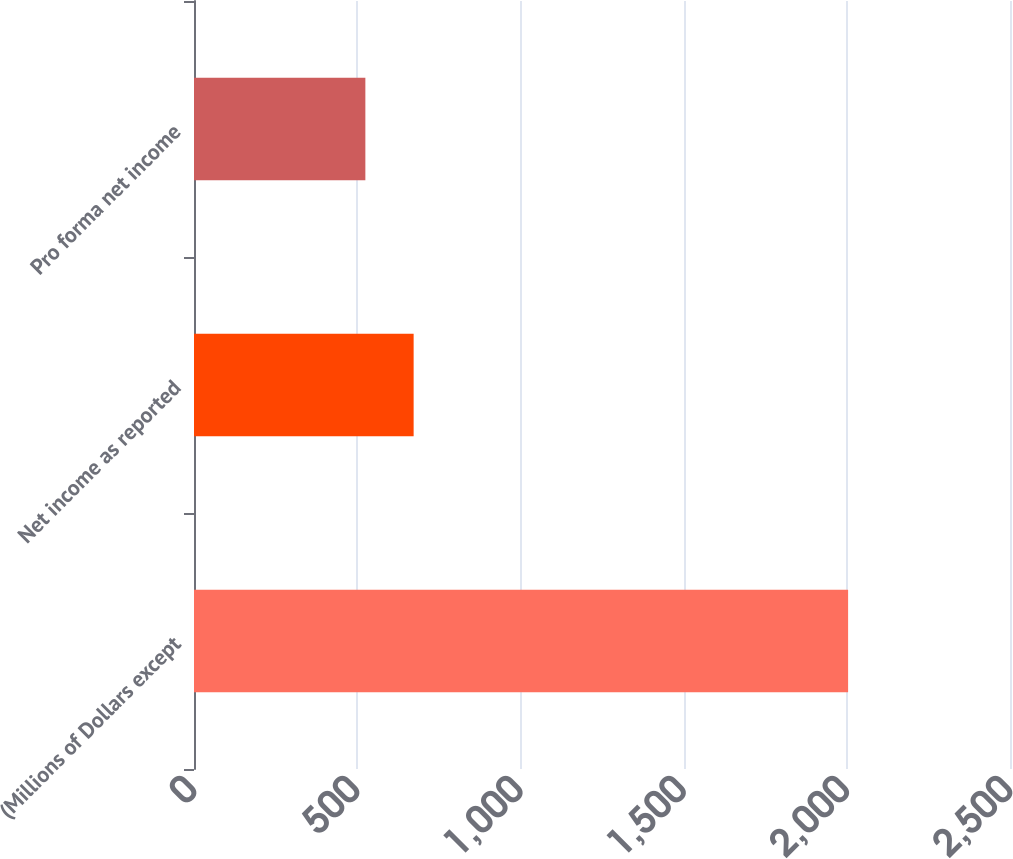Convert chart to OTSL. <chart><loc_0><loc_0><loc_500><loc_500><bar_chart><fcel>(Millions of Dollars except<fcel>Net income as reported<fcel>Pro forma net income<nl><fcel>2004<fcel>672.9<fcel>525<nl></chart> 